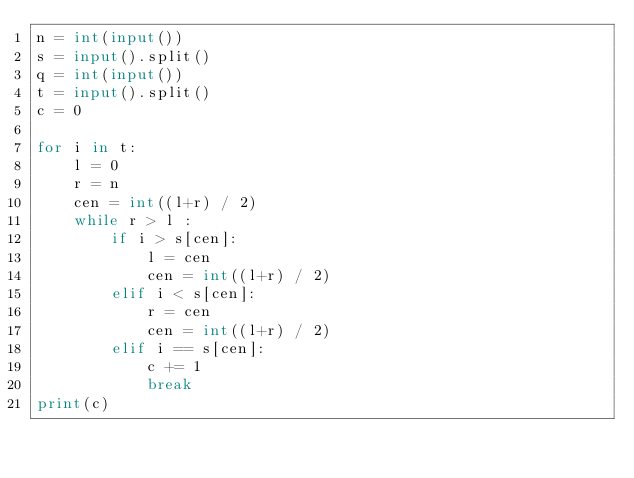Convert code to text. <code><loc_0><loc_0><loc_500><loc_500><_Python_>n = int(input())
s = input().split()
q = int(input())
t = input().split()
c = 0

for i in t:
    l = 0
    r = n
    cen = int((l+r) / 2)
    while r > l :
        if i > s[cen]:
            l = cen
            cen = int((l+r) / 2)
        elif i < s[cen]:
            r = cen
            cen = int((l+r) / 2)
        elif i == s[cen]:
            c += 1
            break
print(c)
</code> 